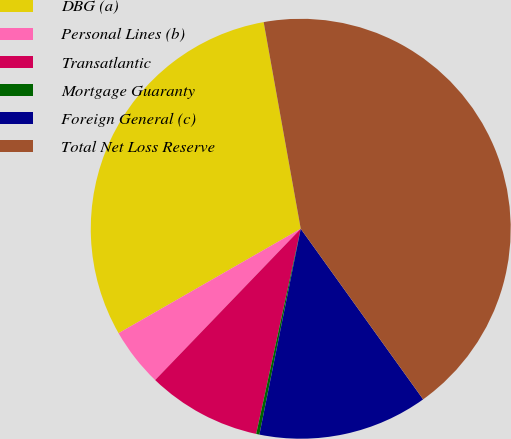Convert chart to OTSL. <chart><loc_0><loc_0><loc_500><loc_500><pie_chart><fcel>DBG (a)<fcel>Personal Lines (b)<fcel>Transatlantic<fcel>Mortgage Guaranty<fcel>Foreign General (c)<fcel>Total Net Loss Reserve<nl><fcel>30.46%<fcel>4.52%<fcel>8.79%<fcel>0.25%<fcel>13.06%<fcel>42.92%<nl></chart> 